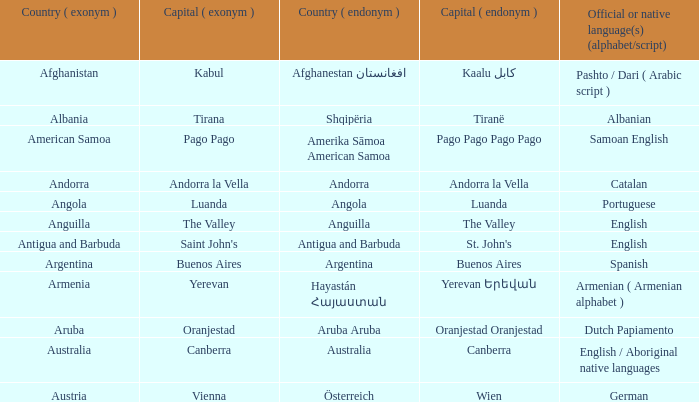What are the official or local languages spoken in the country that has canberra as its capital city? English / Aboriginal native languages. 